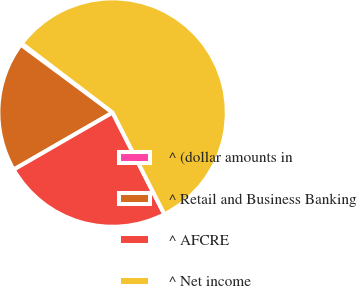<chart> <loc_0><loc_0><loc_500><loc_500><pie_chart><fcel>^ (dollar amounts in<fcel>^ Retail and Business Banking<fcel>^ AFCRE<fcel>^ Net income<nl><fcel>0.21%<fcel>18.47%<fcel>24.17%<fcel>57.15%<nl></chart> 